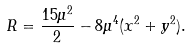<formula> <loc_0><loc_0><loc_500><loc_500>R = \frac { 1 5 \mu ^ { 2 } } { 2 } - 8 \mu ^ { 4 } ( x ^ { 2 } + y ^ { 2 } ) .</formula> 